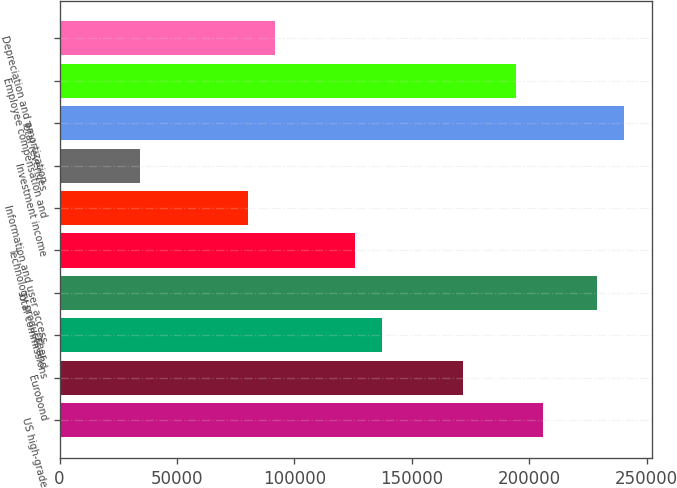<chart> <loc_0><loc_0><loc_500><loc_500><bar_chart><fcel>US high-grade<fcel>Eurobond<fcel>Other<fcel>Total commissions<fcel>Technology products and<fcel>Information and user access<fcel>Investment income<fcel>Total revenues<fcel>Employee compensation and<fcel>Depreciation and amortization<nl><fcel>205990<fcel>171658<fcel>137327<fcel>228878<fcel>125883<fcel>80107.3<fcel>34331.7<fcel>240322<fcel>194546<fcel>91551.2<nl></chart> 